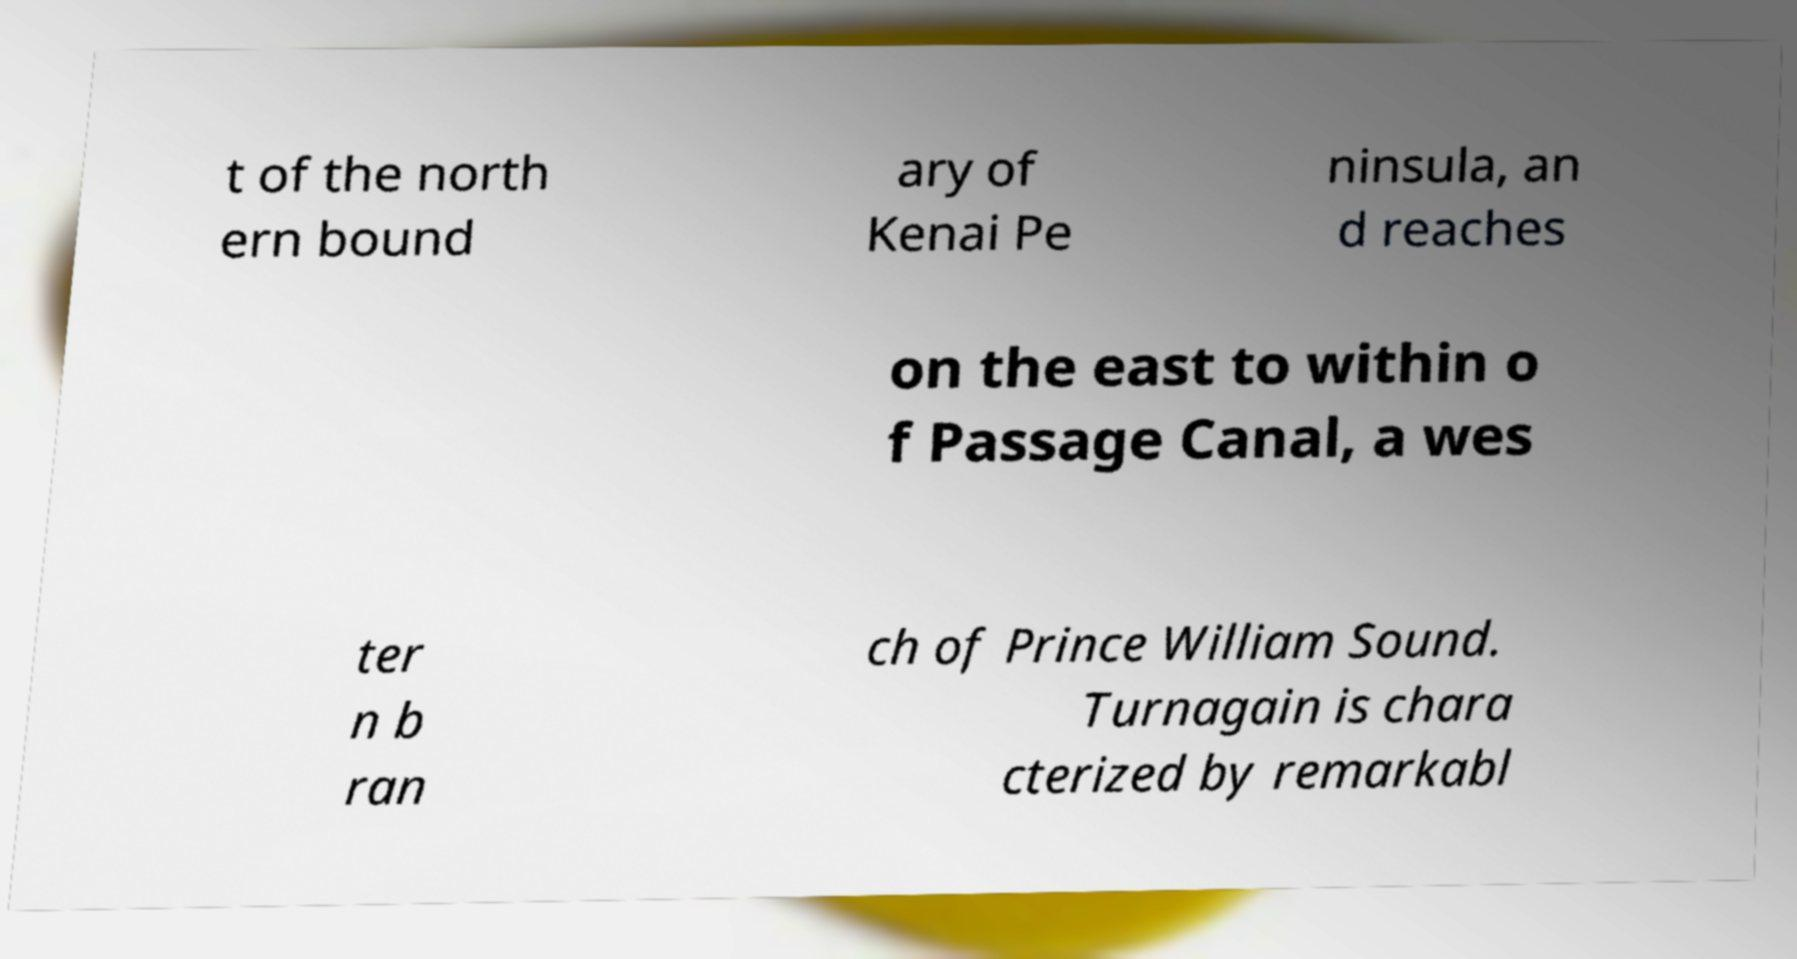Could you assist in decoding the text presented in this image and type it out clearly? t of the north ern bound ary of Kenai Pe ninsula, an d reaches on the east to within o f Passage Canal, a wes ter n b ran ch of Prince William Sound. Turnagain is chara cterized by remarkabl 